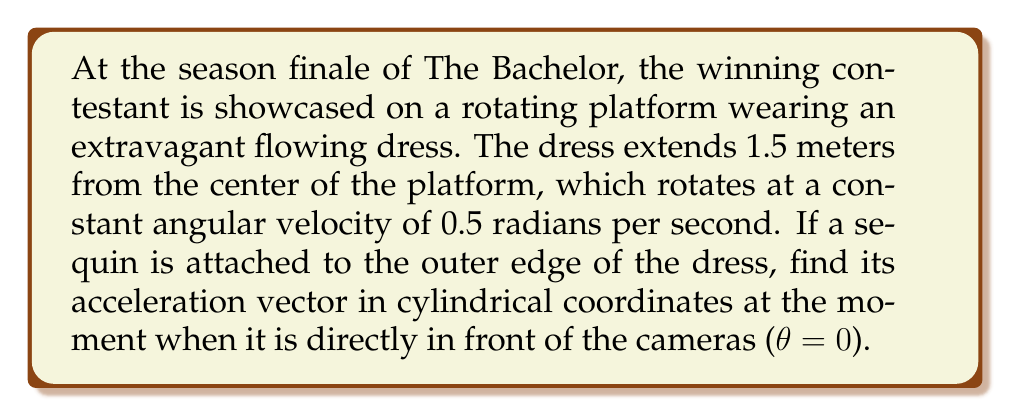Solve this math problem. Let's approach this problem step-by-step using cylindrical coordinates (r, θ, z):

1) First, we need to express the position vector of the sequin:
   $$\mathbf{r} = 1.5\hat{r} + 0\hat{\theta} + 0\hat{z}$$

2) The velocity vector in cylindrical coordinates is given by:
   $$\mathbf{v} = \frac{dr}{dt}\hat{r} + r\frac{d\theta}{dt}\hat{\theta} + \frac{dz}{dt}\hat{z}$$

   Here, $\frac{dr}{dt} = 0$ (constant radius), $\frac{d\theta}{dt} = 0.5$ rad/s (given angular velocity), and $\frac{dz}{dt} = 0$ (no vertical motion).

   So, $$\mathbf{v} = 0\hat{r} + (1.5)(0.5)\hat{\theta} + 0\hat{z} = 0.75\hat{\theta}$$

3) To find acceleration, we need to differentiate the velocity vector. In cylindrical coordinates, the acceleration is:

   $$\mathbf{a} = (\ddot{r} - r\dot{\theta}^2)\hat{r} + (r\ddot{\theta} + 2\dot{r}\dot{\theta})\hat{\theta} + \ddot{z}\hat{z}$$

   Where dots represent time derivatives.

4) Let's calculate each component:
   - $\ddot{r} = 0$ (constant radius)
   - $\dot{\theta} = 0.5$ rad/s (constant angular velocity, so $\ddot{\theta} = 0$)
   - $r = 1.5$ m
   - $\dot{r} = 0$
   - $\ddot{z} = 0$ (no vertical motion)

5) Substituting these values:
   $$\mathbf{a} = (0 - 1.5(0.5)^2)\hat{r} + (1.5(0) + 2(0)(0.5))\hat{\theta} + 0\hat{z}$$

6) Simplifying:
   $$\mathbf{a} = -0.375\hat{r} + 0\hat{\theta} + 0\hat{z}$$

Therefore, the acceleration vector of the sequin in cylindrical coordinates is $-0.375\hat{r}$ m/s².
Answer: $$\mathbf{a} = -0.375\hat{r} \text{ m/s²}$$ 